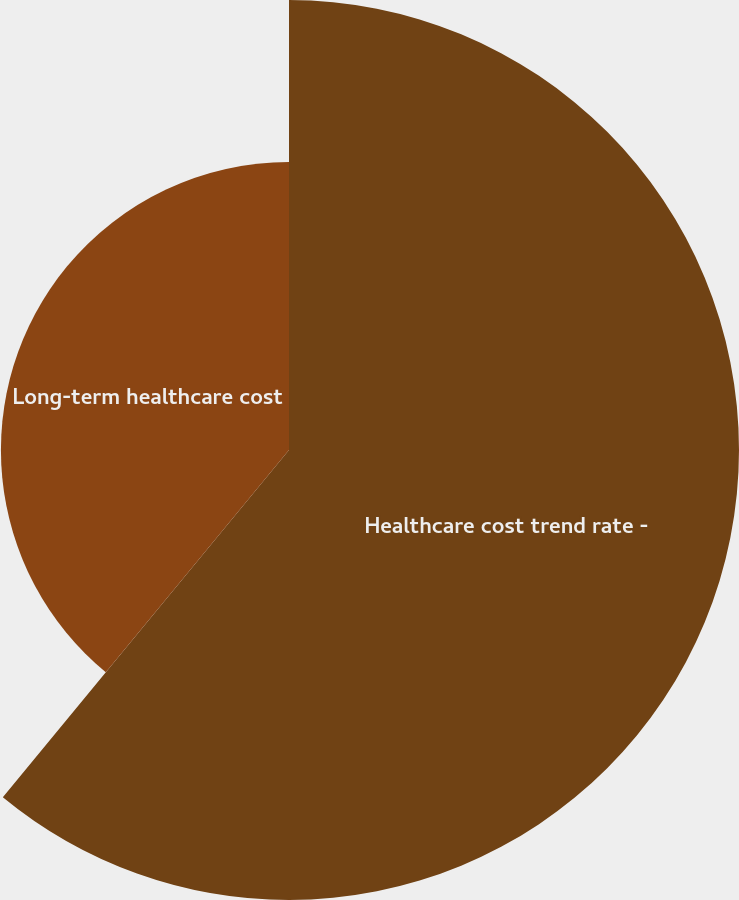Convert chart to OTSL. <chart><loc_0><loc_0><loc_500><loc_500><pie_chart><fcel>Healthcare cost trend rate -<fcel>Long-term healthcare cost<nl><fcel>60.97%<fcel>39.03%<nl></chart> 